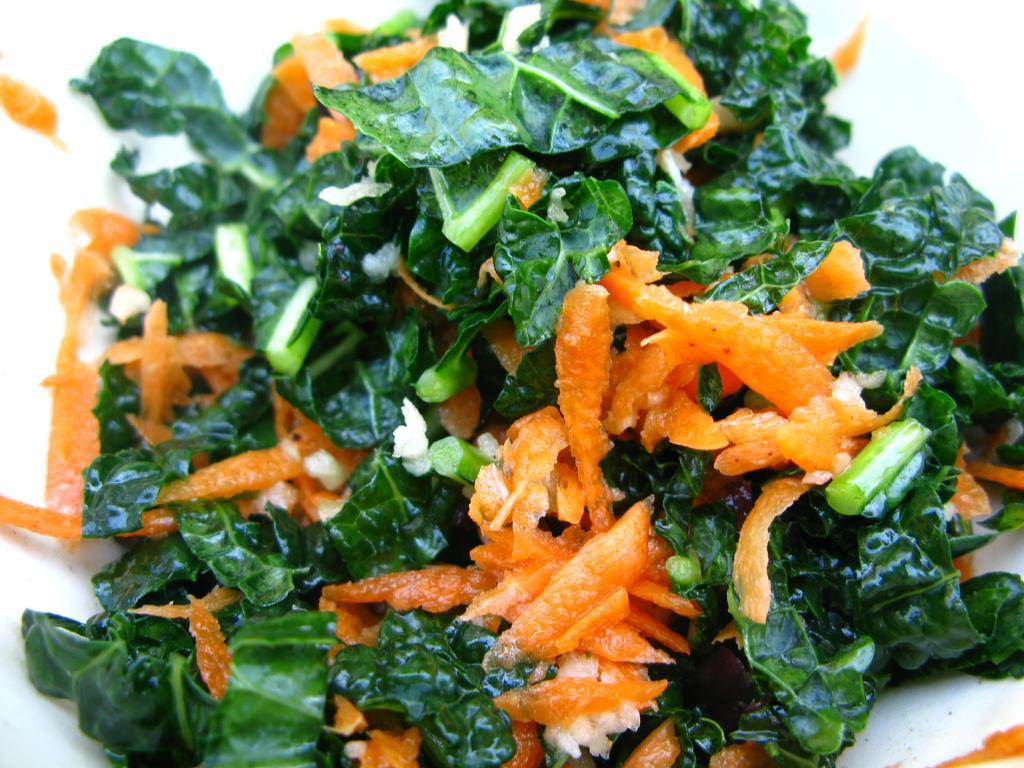Can you describe this image briefly? In this image I see pieces of orange color food and I see number of green leaves. 